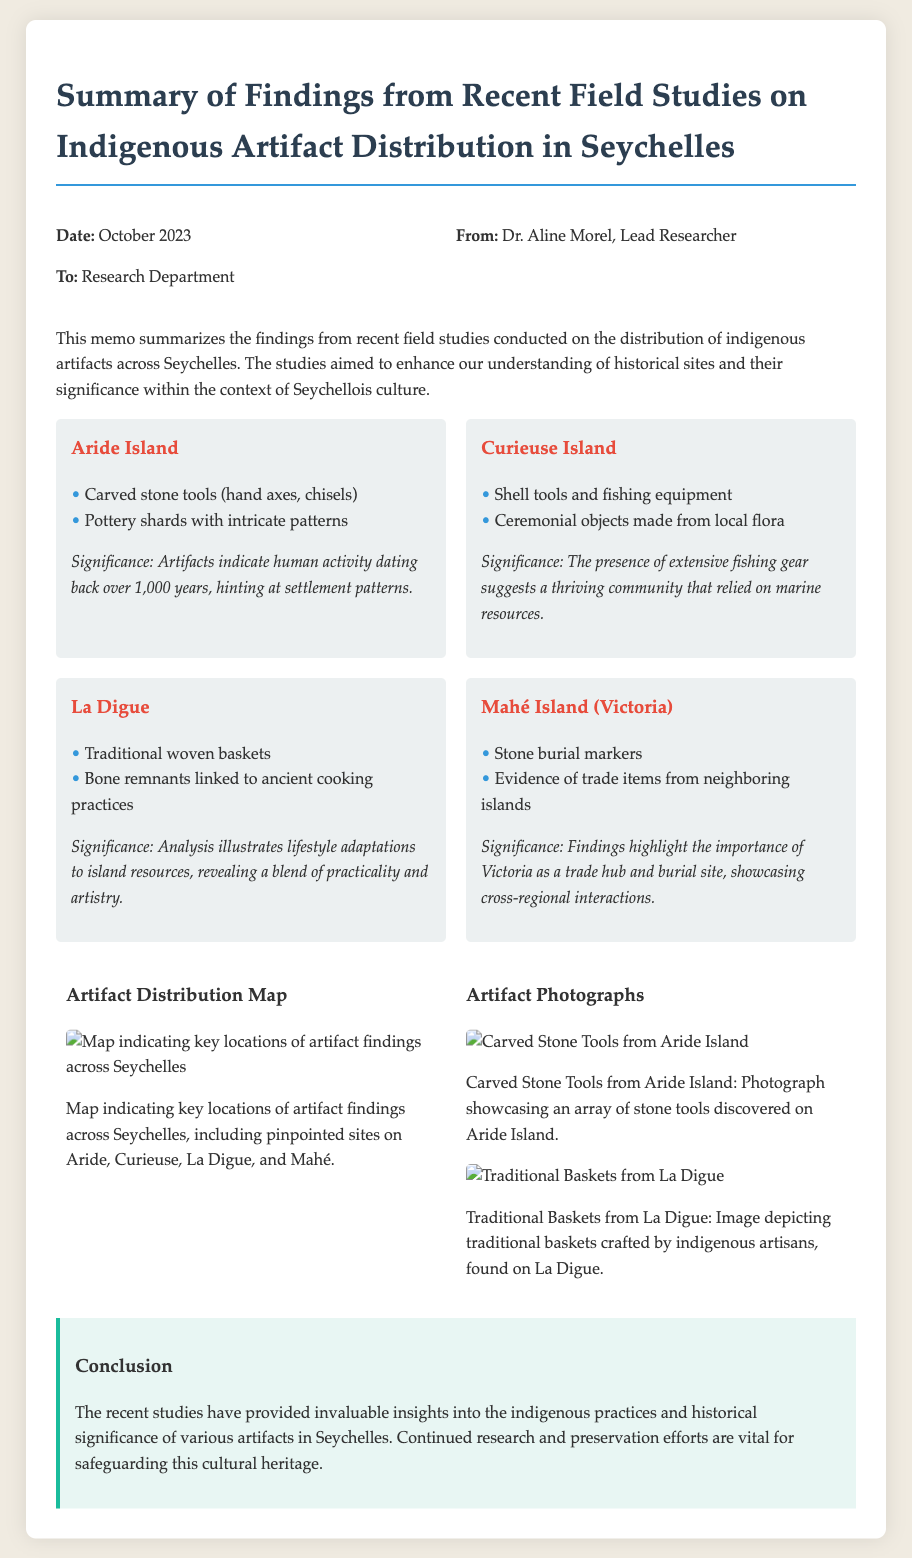What is the date of the memo? The date mentioned in the memo is October 2023.
Answer: October 2023 Who is the lead researcher? The lead researcher identified in the memo is Dr. Aline Morel.
Answer: Dr. Aline Morel What artifacts were found on Aride Island? The artifacts found on Aride Island included carved stone tools and pottery shards.
Answer: Carved stone tools, pottery shards What does the evidence from Mahé Island suggest? The evidence from Mahé Island highlights the importance of Victoria as a trade hub.
Answer: Trade hub Which island had evidence of ancient cooking practices? La Digue is mentioned as the island with evidence linked to ancient cooking practices.
Answer: La Digue What type of objects were found on Curieuse Island? Curieuse Island was noted for having shell tools and ceremonial objects.
Answer: Shell tools, ceremonial objects How many key locations are indicated in the artifact distribution map? The document mentions key locations on Aride, Curieuse, La Digue, and Mahé, amounting to four locations.
Answer: Four What is the significance of artifacts discovered on Aride Island? The significance of artifacts from Aride Island indicates human activity dating back over 1,000 years.
Answer: Over 1,000 years What is the document type of this content? The document is a memo summarizing field study findings.
Answer: Memo 